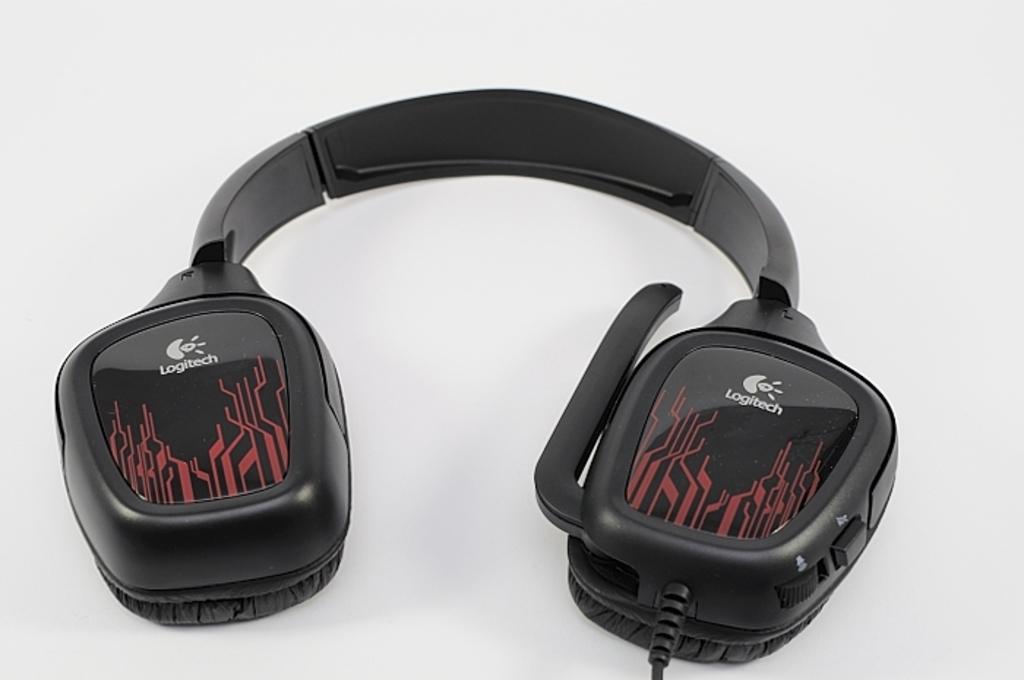What brand of headphones are these?
Ensure brevity in your answer.  Logitech. 